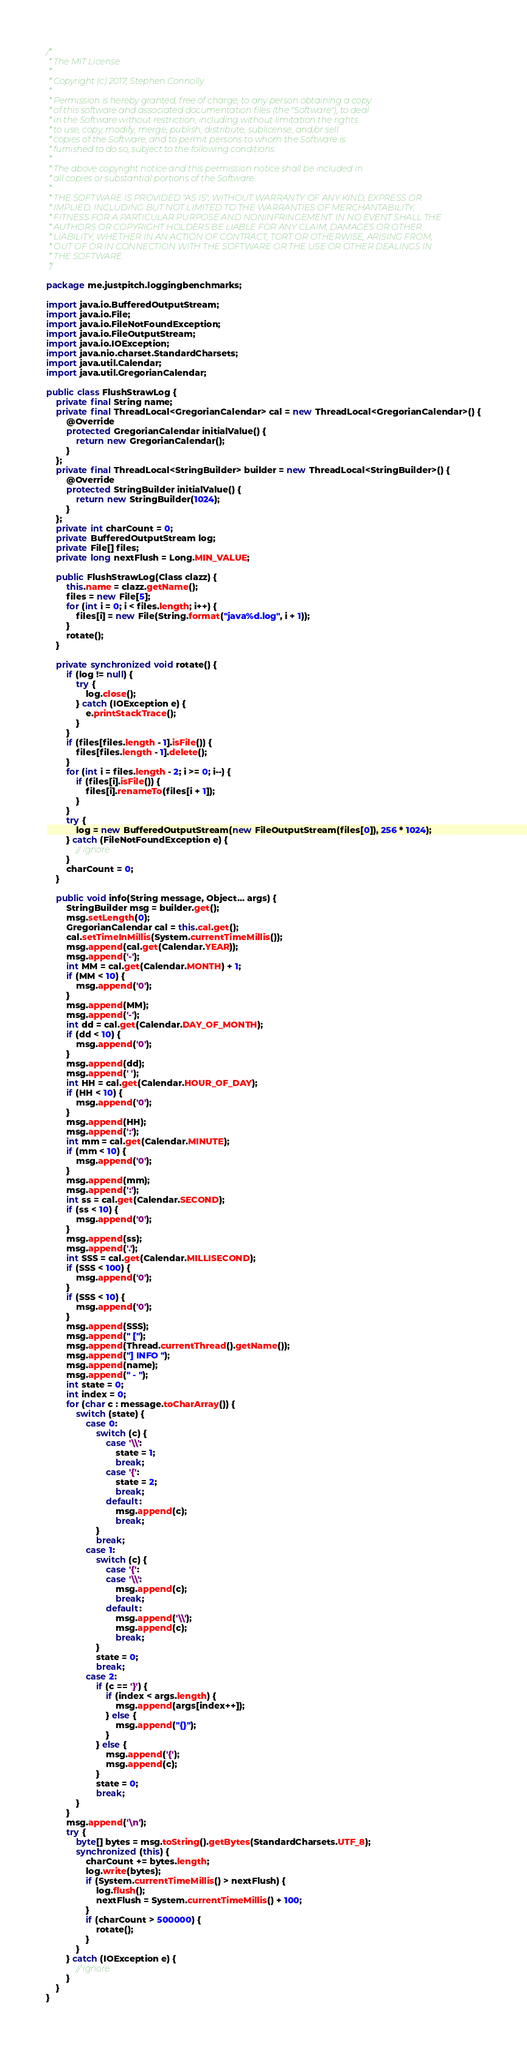Convert code to text. <code><loc_0><loc_0><loc_500><loc_500><_Java_>/*
 * The MIT License
 *
 * Copyright (c) 2017, Stephen Connolly.
 *
 * Permission is hereby granted, free of charge, to any person obtaining a copy
 * of this software and associated documentation files (the "Software"), to deal
 * in the Software without restriction, including without limitation the rights
 * to use, copy, modify, merge, publish, distribute, sublicense, and/or sell
 * copies of the Software, and to permit persons to whom the Software is
 * furnished to do so, subject to the following conditions:
 *
 * The above copyright notice and this permission notice shall be included in
 * all copies or substantial portions of the Software.
 *
 * THE SOFTWARE IS PROVIDED "AS IS", WITHOUT WARRANTY OF ANY KIND, EXPRESS OR
 * IMPLIED, INCLUDING BUT NOT LIMITED TO THE WARRANTIES OF MERCHANTABILITY,
 * FITNESS FOR A PARTICULAR PURPOSE AND NONINFRINGEMENT. IN NO EVENT SHALL THE
 * AUTHORS OR COPYRIGHT HOLDERS BE LIABLE FOR ANY CLAIM, DAMAGES OR OTHER
 * LIABILITY, WHETHER IN AN ACTION OF CONTRACT, TORT OR OTHERWISE, ARISING FROM,
 * OUT OF OR IN CONNECTION WITH THE SOFTWARE OR THE USE OR OTHER DEALINGS IN
 * THE SOFTWARE.
 */

package me.justpitch.loggingbenchmarks;

import java.io.BufferedOutputStream;
import java.io.File;
import java.io.FileNotFoundException;
import java.io.FileOutputStream;
import java.io.IOException;
import java.nio.charset.StandardCharsets;
import java.util.Calendar;
import java.util.GregorianCalendar;

public class FlushStrawLog {
    private final String name;
    private final ThreadLocal<GregorianCalendar> cal = new ThreadLocal<GregorianCalendar>() {
        @Override
        protected GregorianCalendar initialValue() {
            return new GregorianCalendar();
        }
    };
    private final ThreadLocal<StringBuilder> builder = new ThreadLocal<StringBuilder>() {
        @Override
        protected StringBuilder initialValue() {
            return new StringBuilder(1024);
        }
    };
    private int charCount = 0;
    private BufferedOutputStream log;
    private File[] files;
    private long nextFlush = Long.MIN_VALUE;

    public FlushStrawLog(Class clazz) {
        this.name = clazz.getName();
        files = new File[5];
        for (int i = 0; i < files.length; i++) {
            files[i] = new File(String.format("java%d.log", i + 1));
        }
        rotate();
    }

    private synchronized void rotate() {
        if (log != null) {
            try {
                log.close();
            } catch (IOException e) {
                e.printStackTrace();
            }
        }
        if (files[files.length - 1].isFile()) {
            files[files.length - 1].delete();
        }
        for (int i = files.length - 2; i >= 0; i--) {
            if (files[i].isFile()) {
                files[i].renameTo(files[i + 1]);
            }
        }
        try {
            log = new BufferedOutputStream(new FileOutputStream(files[0]), 256 * 1024);
        } catch (FileNotFoundException e) {
            // ignore
        }
        charCount = 0;
    }

    public void info(String message, Object... args) {
        StringBuilder msg = builder.get();
        msg.setLength(0);
        GregorianCalendar cal = this.cal.get();
        cal.setTimeInMillis(System.currentTimeMillis());
        msg.append(cal.get(Calendar.YEAR));
        msg.append('-');
        int MM = cal.get(Calendar.MONTH) + 1;
        if (MM < 10) {
            msg.append('0');
        }
        msg.append(MM);
        msg.append('-');
        int dd = cal.get(Calendar.DAY_OF_MONTH);
        if (dd < 10) {
            msg.append('0');
        }
        msg.append(dd);
        msg.append(' ');
        int HH = cal.get(Calendar.HOUR_OF_DAY);
        if (HH < 10) {
            msg.append('0');
        }
        msg.append(HH);
        msg.append(':');
        int mm = cal.get(Calendar.MINUTE);
        if (mm < 10) {
            msg.append('0');
        }
        msg.append(mm);
        msg.append(':');
        int ss = cal.get(Calendar.SECOND);
        if (ss < 10) {
            msg.append('0');
        }
        msg.append(ss);
        msg.append('.');
        int SSS = cal.get(Calendar.MILLISECOND);
        if (SSS < 100) {
            msg.append('0');
        }
        if (SSS < 10) {
            msg.append('0');
        }
        msg.append(SSS);
        msg.append(" [");
        msg.append(Thread.currentThread().getName());
        msg.append("] INFO ");
        msg.append(name);
        msg.append(" - ");
        int state = 0;
        int index = 0;
        for (char c : message.toCharArray()) {
            switch (state) {
                case 0:
                    switch (c) {
                        case '\\':
                            state = 1;
                            break;
                        case '{':
                            state = 2;
                            break;
                        default:
                            msg.append(c);
                            break;
                    }
                    break;
                case 1:
                    switch (c) {
                        case '{':
                        case '\\':
                            msg.append(c);
                            break;
                        default:
                            msg.append('\\');
                            msg.append(c);
                            break;
                    }
                    state = 0;
                    break;
                case 2:
                    if (c == '}') {
                        if (index < args.length) {
                            msg.append(args[index++]);
                        } else {
                            msg.append("{}");
                        }
                    } else {
                        msg.append('{');
                        msg.append(c);
                    }
                    state = 0;
                    break;
            }
        }
        msg.append('\n');
        try {
            byte[] bytes = msg.toString().getBytes(StandardCharsets.UTF_8);
            synchronized (this) {
                charCount += bytes.length;
                log.write(bytes);
                if (System.currentTimeMillis() > nextFlush) {
                    log.flush();
                    nextFlush = System.currentTimeMillis() + 100;
                }
                if (charCount > 500000) {
                    rotate();
                }
            }
        } catch (IOException e) {
            // ignore
        }
    }
}
</code> 